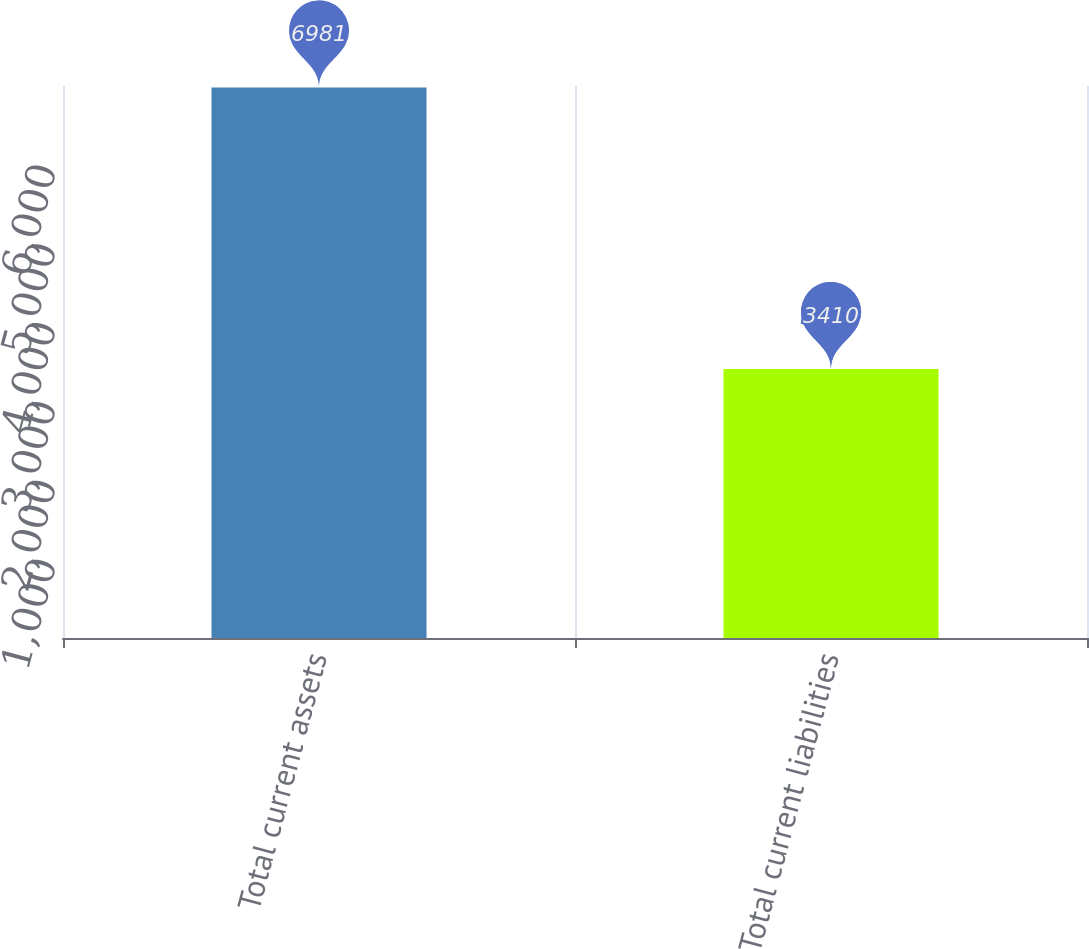Convert chart to OTSL. <chart><loc_0><loc_0><loc_500><loc_500><bar_chart><fcel>Total current assets<fcel>Total current liabilities<nl><fcel>6981<fcel>3410<nl></chart> 